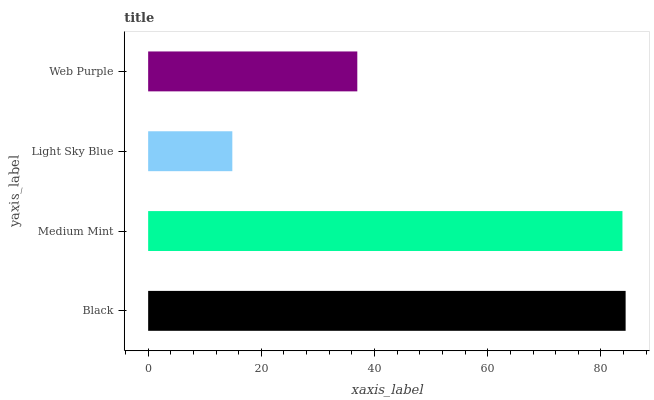Is Light Sky Blue the minimum?
Answer yes or no. Yes. Is Black the maximum?
Answer yes or no. Yes. Is Medium Mint the minimum?
Answer yes or no. No. Is Medium Mint the maximum?
Answer yes or no. No. Is Black greater than Medium Mint?
Answer yes or no. Yes. Is Medium Mint less than Black?
Answer yes or no. Yes. Is Medium Mint greater than Black?
Answer yes or no. No. Is Black less than Medium Mint?
Answer yes or no. No. Is Medium Mint the high median?
Answer yes or no. Yes. Is Web Purple the low median?
Answer yes or no. Yes. Is Light Sky Blue the high median?
Answer yes or no. No. Is Black the low median?
Answer yes or no. No. 